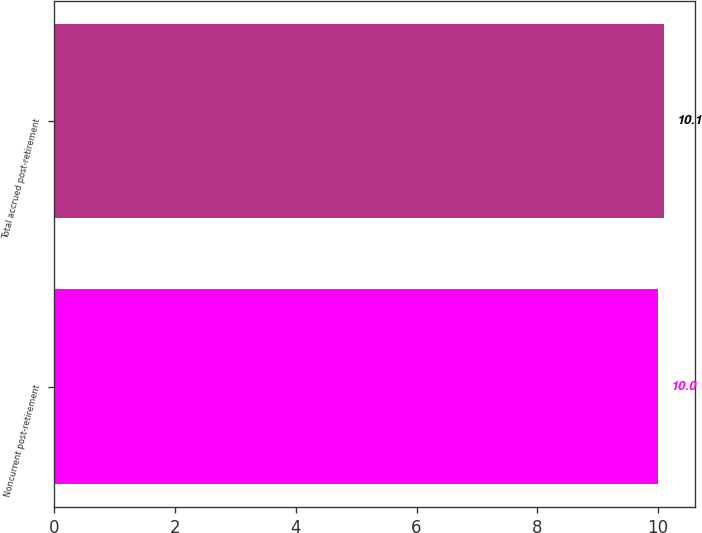<chart> <loc_0><loc_0><loc_500><loc_500><bar_chart><fcel>Noncurrent post-retirement<fcel>Total accrued post-retirement<nl><fcel>10<fcel>10.1<nl></chart> 